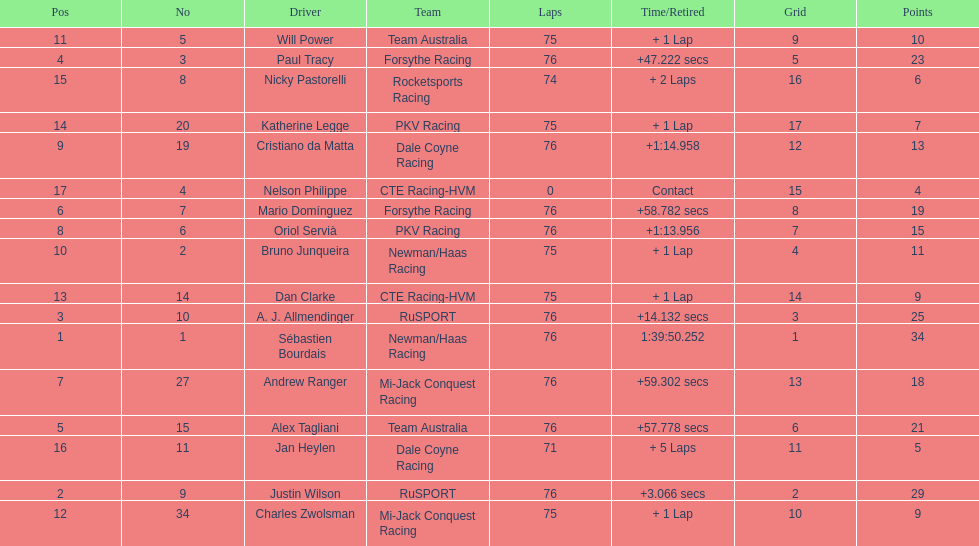Which driver earned the least amount of points. Nelson Philippe. 